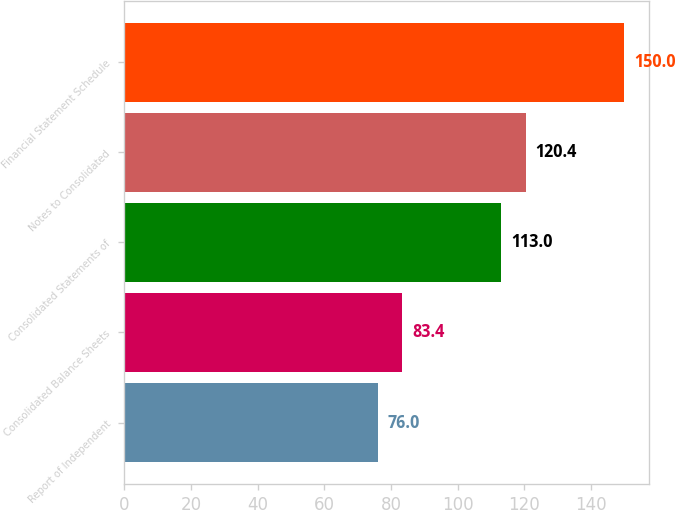Convert chart. <chart><loc_0><loc_0><loc_500><loc_500><bar_chart><fcel>Report of Independent<fcel>Consolidated Balance Sheets<fcel>Consolidated Statements of<fcel>Notes to Consolidated<fcel>Financial Statement Schedule<nl><fcel>76<fcel>83.4<fcel>113<fcel>120.4<fcel>150<nl></chart> 